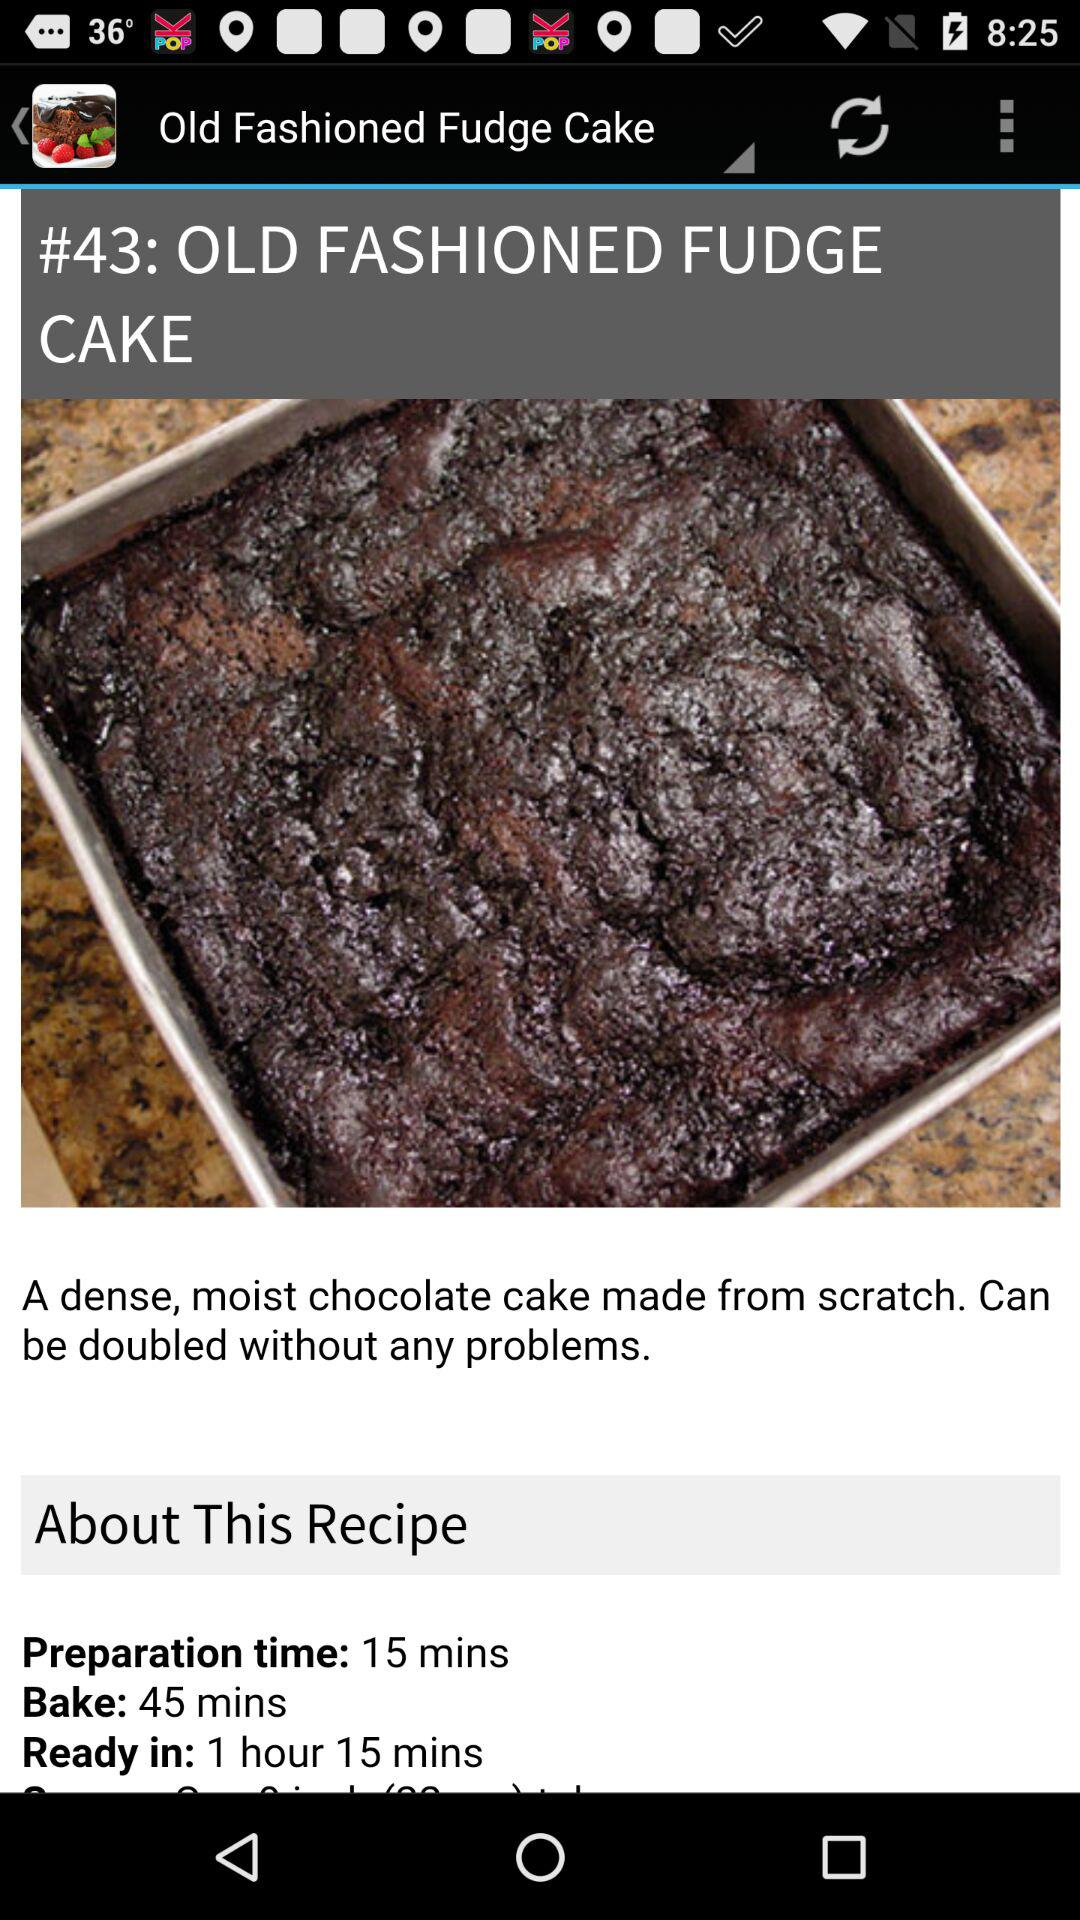What is the name of the recipe? The name of the recipe is "Old Fashioned Fudge Cake". 